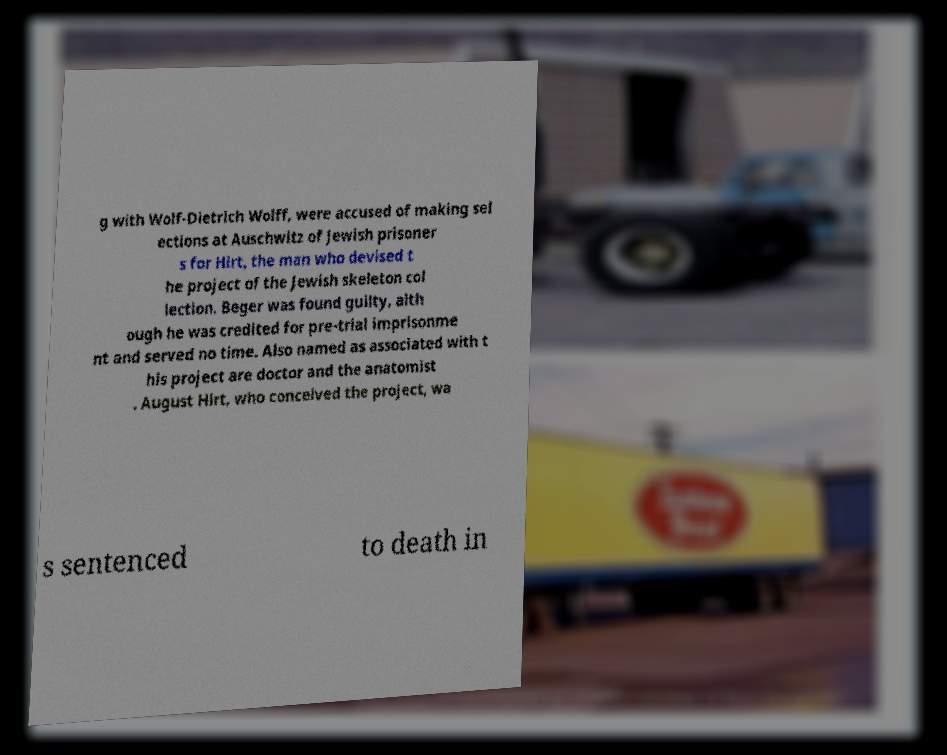Can you accurately transcribe the text from the provided image for me? g with Wolf-Dietrich Wolff, were accused of making sel ections at Auschwitz of Jewish prisoner s for Hirt, the man who devised t he project of the Jewish skeleton col lection. Beger was found guilty, alth ough he was credited for pre-trial imprisonme nt and served no time. Also named as associated with t his project are doctor and the anatomist . August Hirt, who conceived the project, wa s sentenced to death in 